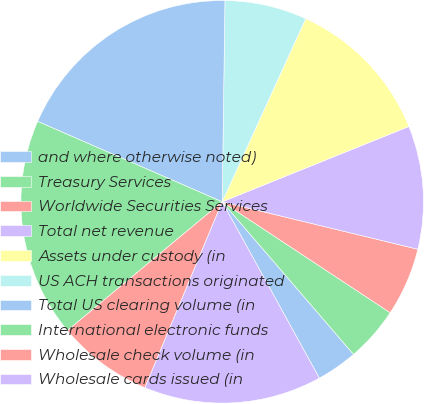Convert chart to OTSL. <chart><loc_0><loc_0><loc_500><loc_500><pie_chart><fcel>and where otherwise noted)<fcel>Treasury Services<fcel>Worldwide Securities Services<fcel>Total net revenue<fcel>Assets under custody (in<fcel>US ACH transactions originated<fcel>Total US clearing volume (in<fcel>International electronic funds<fcel>Wholesale check volume (in<fcel>Wholesale cards issued (in<nl><fcel>3.3%<fcel>4.4%<fcel>5.5%<fcel>9.89%<fcel>12.09%<fcel>6.59%<fcel>18.68%<fcel>17.58%<fcel>7.69%<fcel>14.28%<nl></chart> 